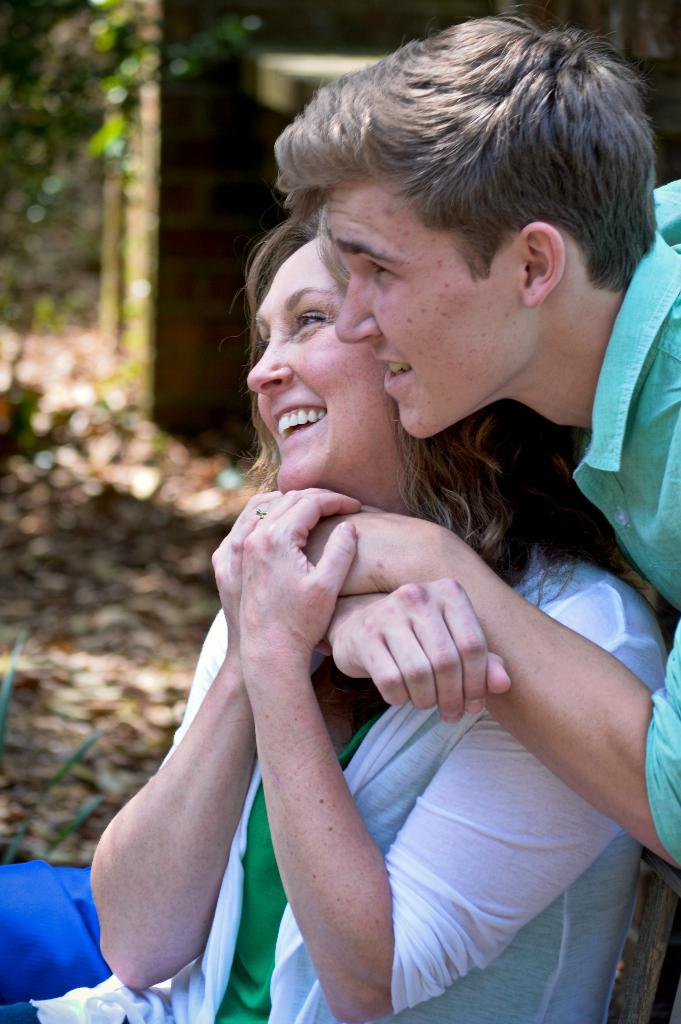What is happening between the two people in the image? There is a person holding another person in the image. Can you describe the background of the image? The background of the image is blurred. What type of punishment is being administered to the giants in the image? There are no giants present in the image, and therefore no punishment is being administered. What does the pig have to do with the image? There is no pig present in the image. 